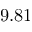Convert formula to latex. <formula><loc_0><loc_0><loc_500><loc_500>9 . 8 1</formula> 